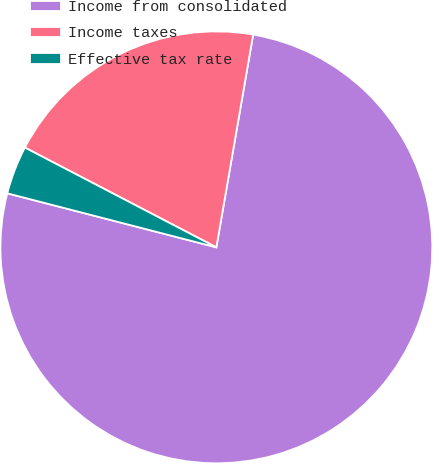Convert chart to OTSL. <chart><loc_0><loc_0><loc_500><loc_500><pie_chart><fcel>Income from consolidated<fcel>Income taxes<fcel>Effective tax rate<nl><fcel>76.3%<fcel>20.08%<fcel>3.62%<nl></chart> 